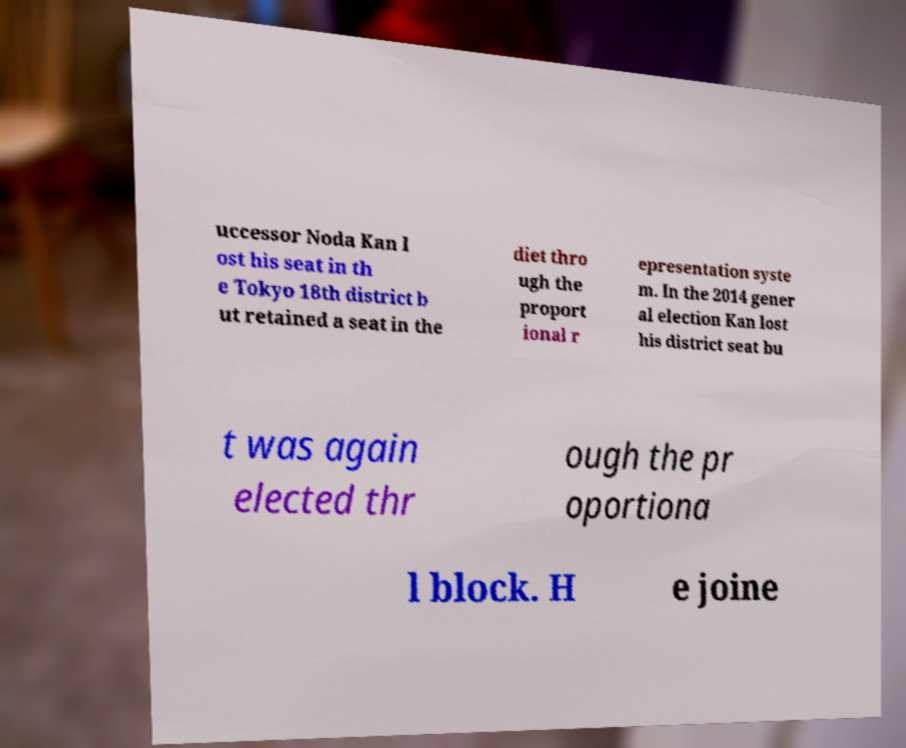Can you read and provide the text displayed in the image?This photo seems to have some interesting text. Can you extract and type it out for me? uccessor Noda Kan l ost his seat in th e Tokyo 18th district b ut retained a seat in the diet thro ugh the proport ional r epresentation syste m. In the 2014 gener al election Kan lost his district seat bu t was again elected thr ough the pr oportiona l block. H e joine 